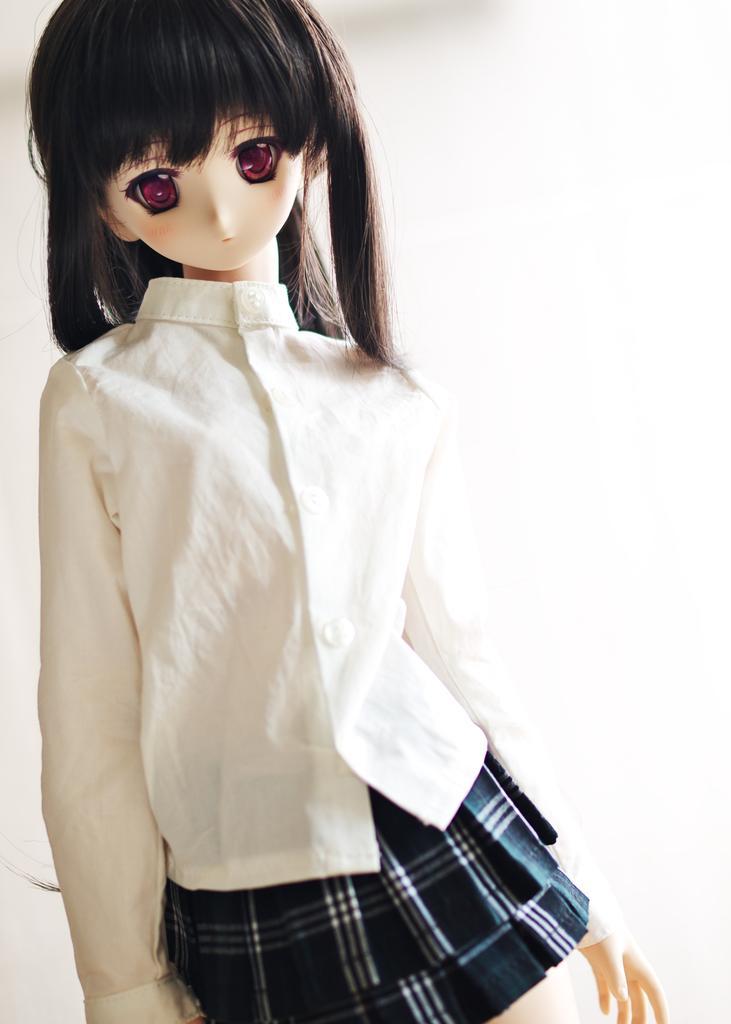Can you describe this image briefly? In this image we can see a doll, it is dressed with a white shirt and a blue skirt. 